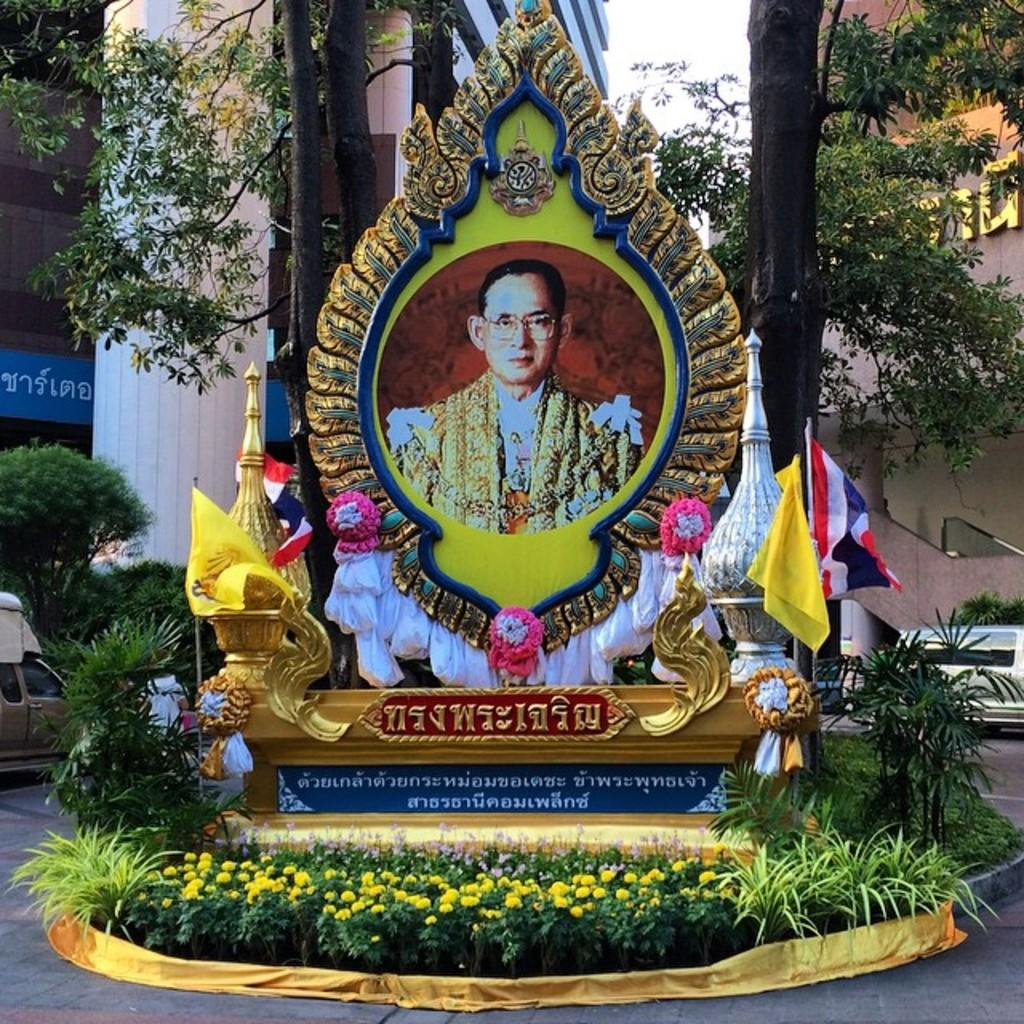What is the main subject of the image? There is a memorial in the image. Can you describe any specific details about the memorial? There is a person's photo in the image, which is likely a part of the memorial. What else can be seen in the image besides the memorial? There is a road, a flag, trees, flowers, a plant, and many buildings visible in the image. How would you describe the sky in the image? The sky is white in the image. How many volleyballs are visible in the image? There are no volleyballs present in the image. What idea does the memorial represent in the image? The image does not provide any information about the specific idea or concept that the memorial represents. 